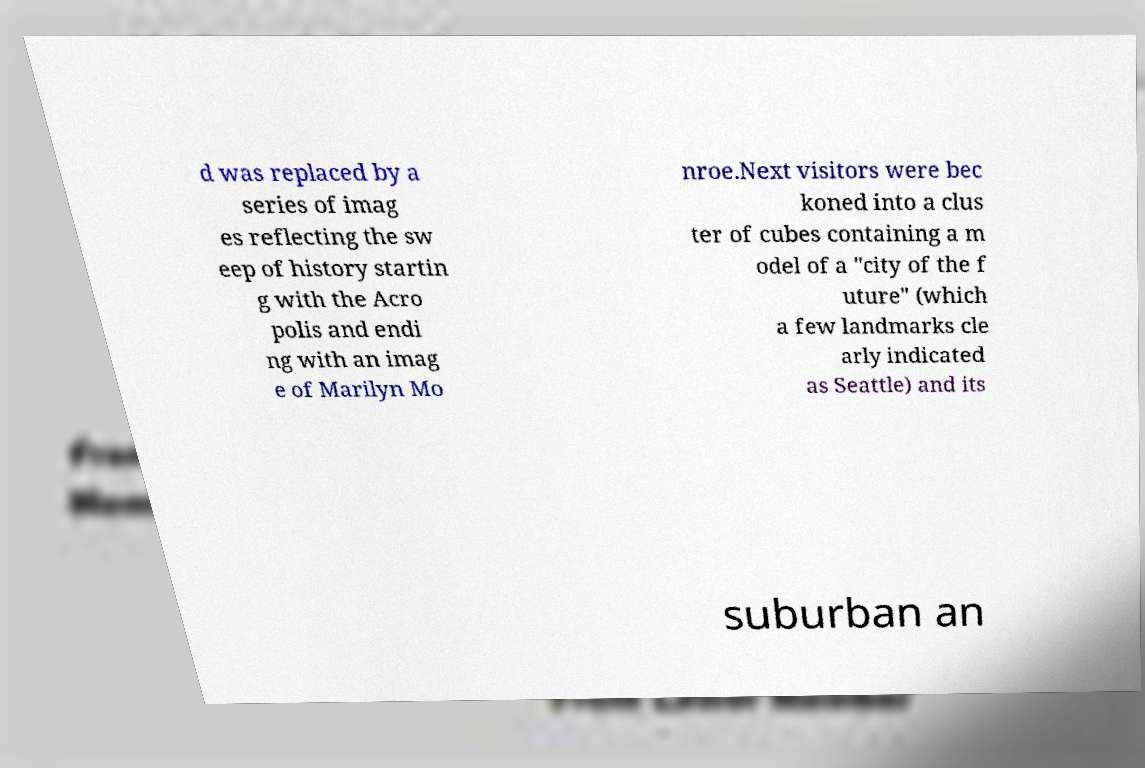For documentation purposes, I need the text within this image transcribed. Could you provide that? d was replaced by a series of imag es reflecting the sw eep of history startin g with the Acro polis and endi ng with an imag e of Marilyn Mo nroe.Next visitors were bec koned into a clus ter of cubes containing a m odel of a "city of the f uture" (which a few landmarks cle arly indicated as Seattle) and its suburban an 